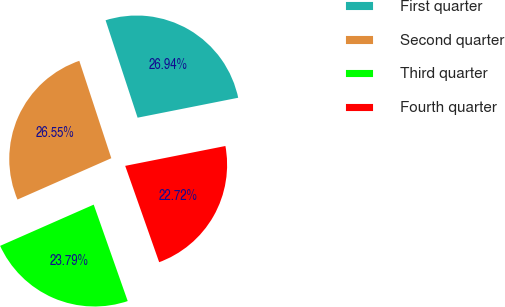Convert chart to OTSL. <chart><loc_0><loc_0><loc_500><loc_500><pie_chart><fcel>First quarter<fcel>Second quarter<fcel>Third quarter<fcel>Fourth quarter<nl><fcel>26.94%<fcel>26.55%<fcel>23.79%<fcel>22.72%<nl></chart> 